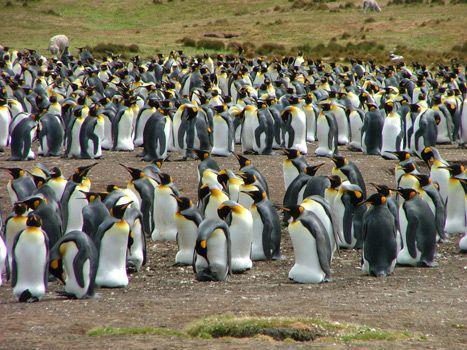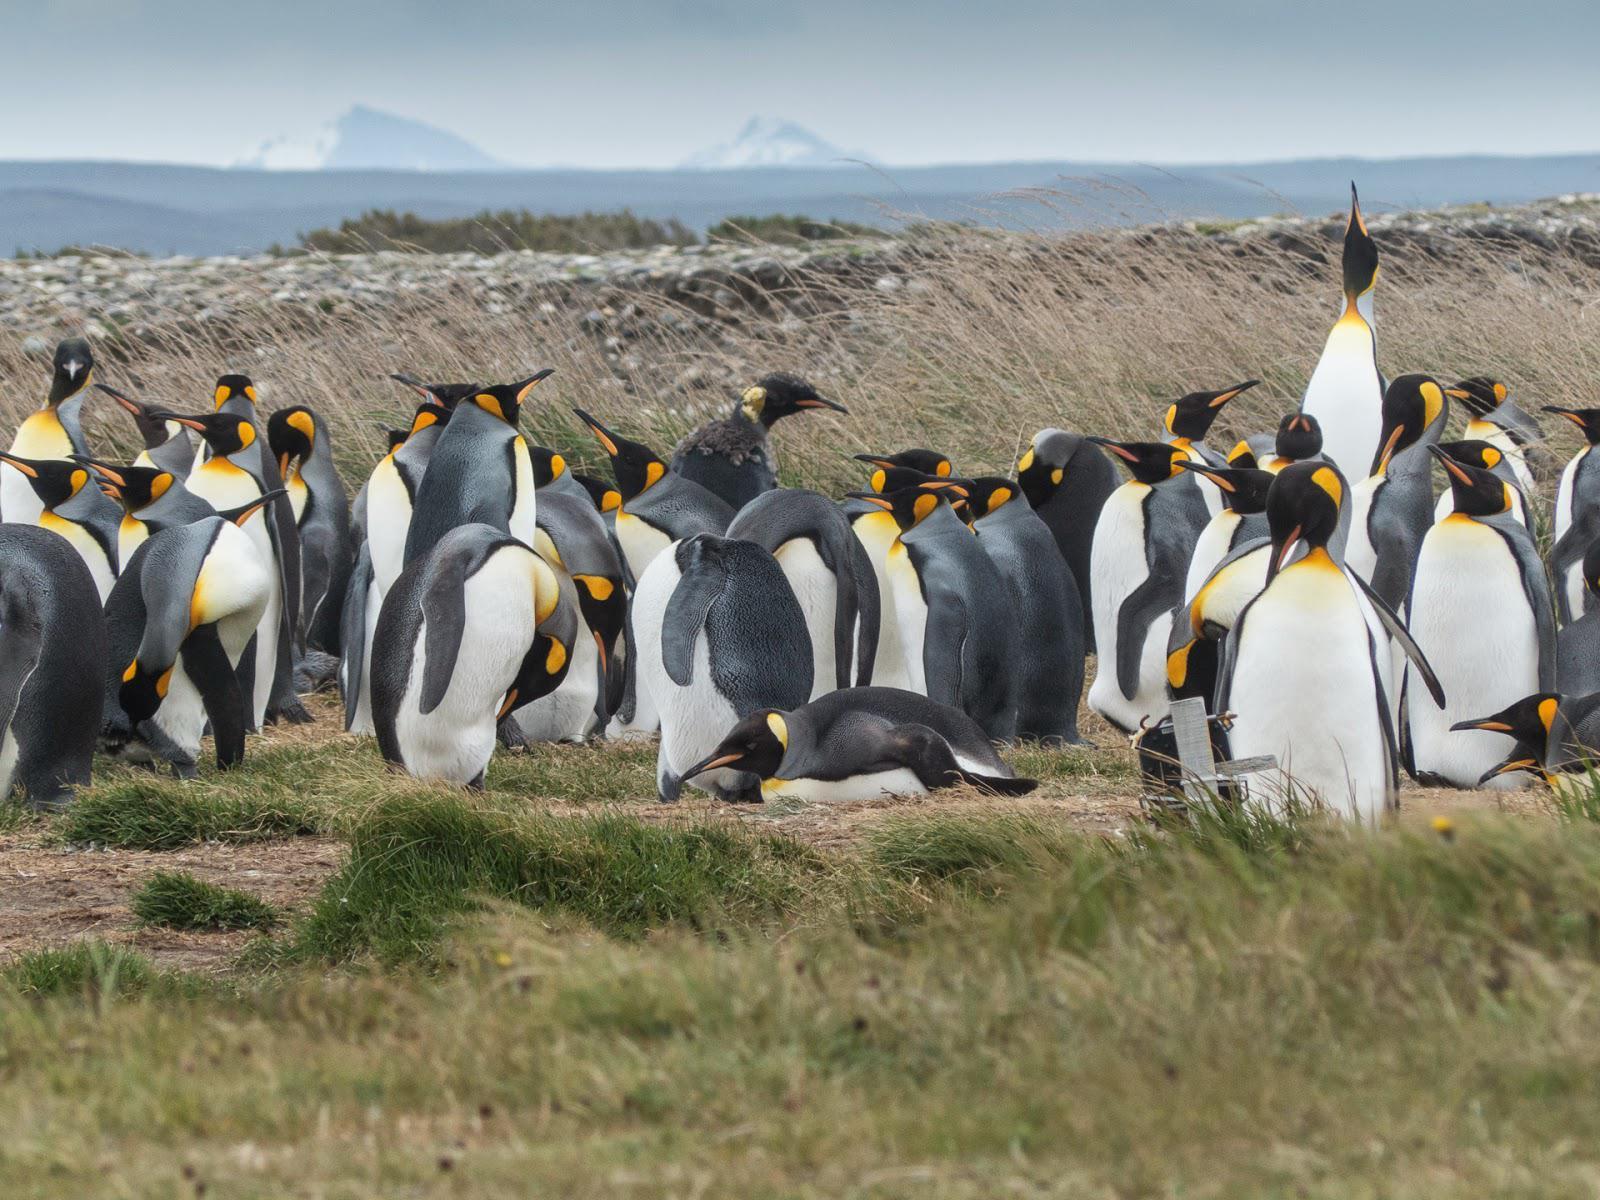The first image is the image on the left, the second image is the image on the right. For the images shown, is this caption "A brown-feathered penguin is standing at the front of a mass of penguins." true? Answer yes or no. No. 